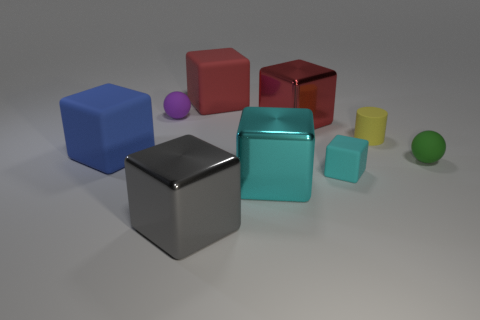Are the sphere to the right of the purple ball and the large block that is behind the purple matte ball made of the same material?
Ensure brevity in your answer.  Yes. What number of other cubes have the same color as the small cube?
Make the answer very short. 1. There is a tiny rubber object that is both in front of the large blue matte block and on the left side of the small green matte ball; what shape is it?
Your answer should be very brief. Cube. The tiny thing that is both left of the yellow rubber cylinder and in front of the blue block is what color?
Make the answer very short. Cyan. Is the number of metal cubes that are behind the tiny cyan rubber cube greater than the number of large metallic cubes to the right of the green matte object?
Make the answer very short. Yes. What is the color of the small matte ball that is on the left side of the small block?
Give a very brief answer. Purple. There is a large metallic object behind the yellow matte object; does it have the same shape as the rubber object that is on the left side of the tiny purple sphere?
Make the answer very short. Yes. Are there any cyan blocks of the same size as the blue block?
Your answer should be compact. Yes. What is the tiny ball to the right of the big gray metallic thing made of?
Offer a very short reply. Rubber. Do the large thing that is to the left of the large gray object and the green sphere have the same material?
Provide a succinct answer. Yes. 